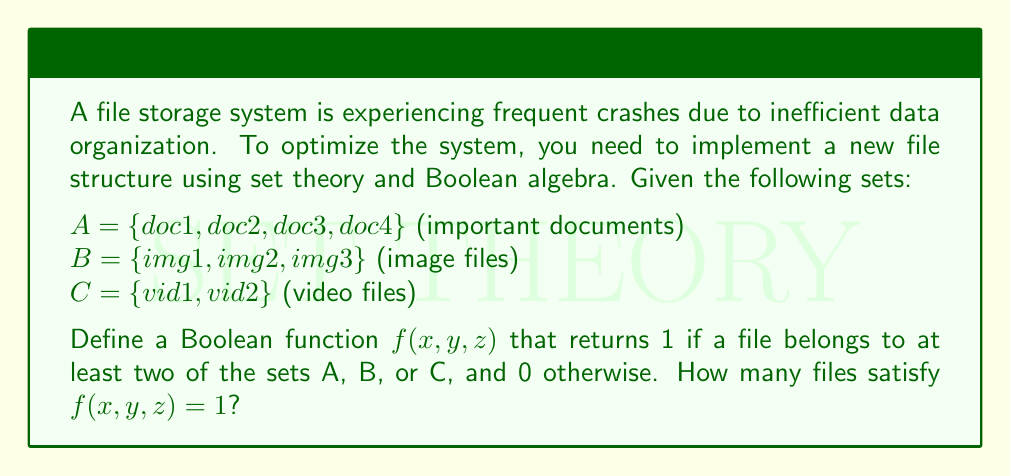Could you help me with this problem? To solve this problem, we need to use set theory and Boolean algebra concepts:

1. First, let's define the Boolean variables:
   $x$: file belongs to set A
   $y$: file belongs to set B
   $z$: file belongs to set C

2. The Boolean function $f(x, y, z)$ can be expressed as:
   $f(x, y, z) = xy + xz + yz$

   This is because the function should return 1 if at least two of x, y, or z are true.

3. Now, we need to check each file against this function:

   For files in A:
   - doc1, doc2, doc3, doc4: $f(1, 0, 0) = 0$

   For files in B:
   - img1, img2, img3: $f(0, 1, 0) = 0$

   For files in C:
   - vid1, vid2: $f(0, 0, 1) = 0$

4. As we can see, no file belongs to more than one set, so no file satisfies $f(x, y, z) = 1$.

5. To optimize the file storage system and reduce crashes, we could reorganize the files so that some belong to multiple sets. For example, moving doc1 to both A and B would result in $f(1, 1, 0) = 1$ for that file.
Answer: 0 files satisfy $f(x, y, z) = 1$ 